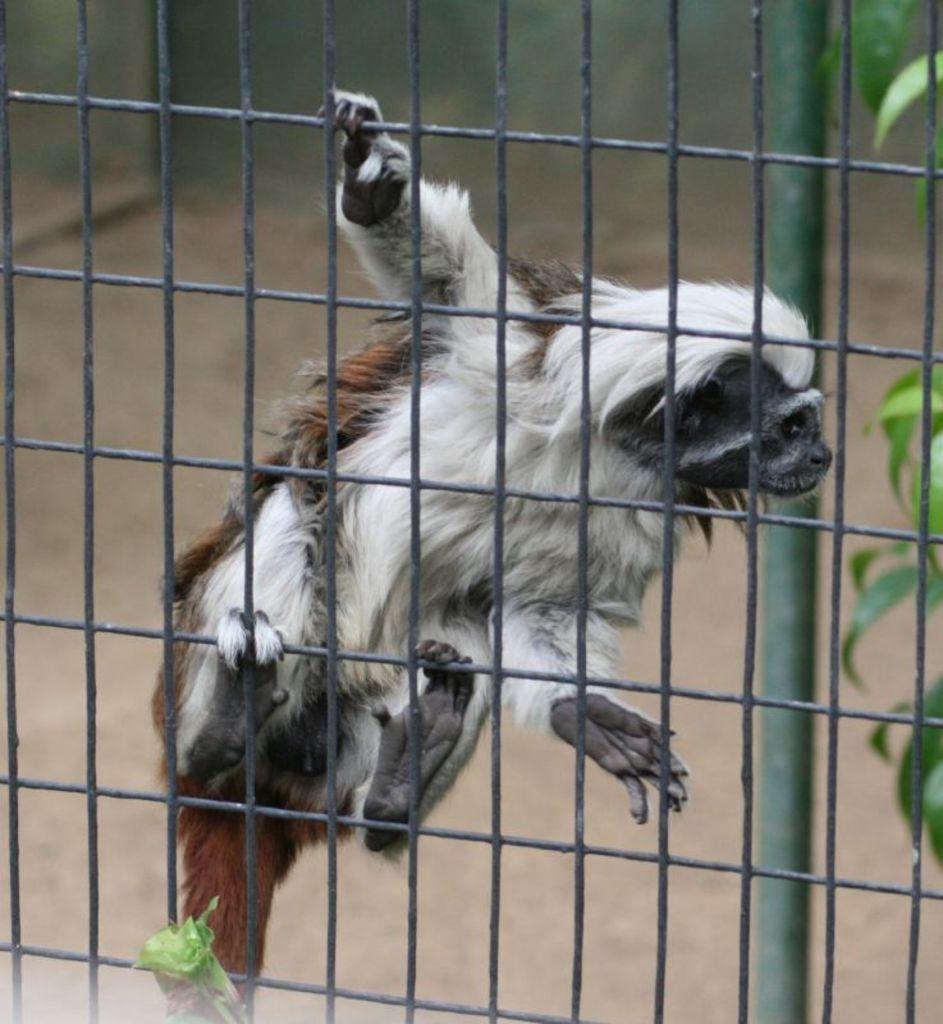What is the main subject of the image? There is an animal on a mesh in the image. What can be seen in the background of the image? There is a pole in the background of the image. What type of vegetation is present in the image? Leaves are present in the image. How would you describe the background of the image? The background is blurred in the image. How many stems can be seen growing from the animal's fingers in the image? There are no stems or fingers visible in the image; it features an animal on a mesh with a blurred background and a pole in the distance. 